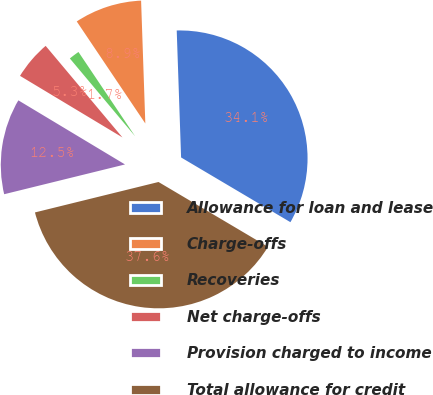Convert chart. <chart><loc_0><loc_0><loc_500><loc_500><pie_chart><fcel>Allowance for loan and lease<fcel>Charge-offs<fcel>Recoveries<fcel>Net charge-offs<fcel>Provision charged to income<fcel>Total allowance for credit<nl><fcel>34.06%<fcel>8.87%<fcel>1.69%<fcel>5.28%<fcel>12.46%<fcel>37.65%<nl></chart> 